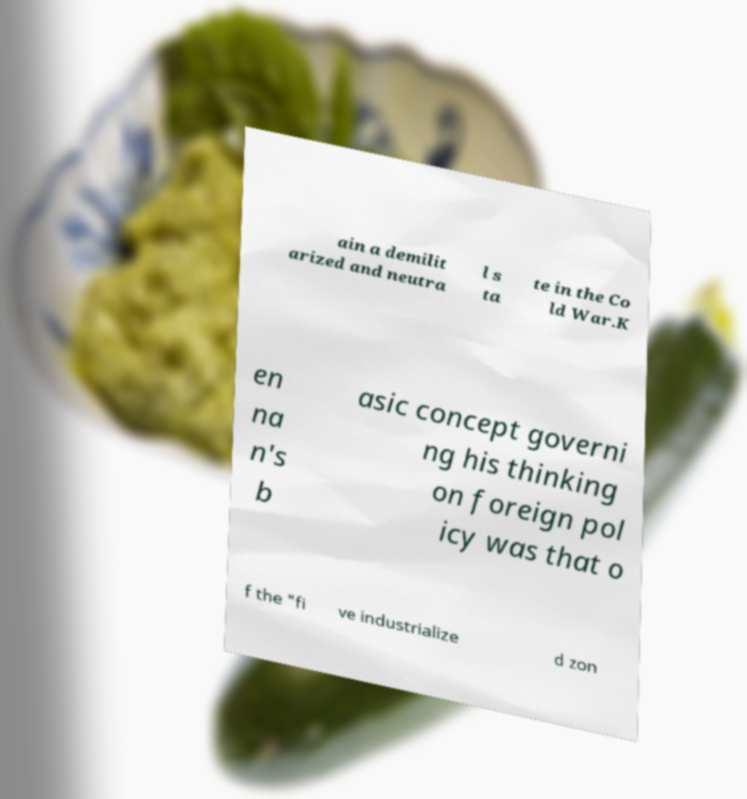There's text embedded in this image that I need extracted. Can you transcribe it verbatim? ain a demilit arized and neutra l s ta te in the Co ld War.K en na n's b asic concept governi ng his thinking on foreign pol icy was that o f the "fi ve industrialize d zon 